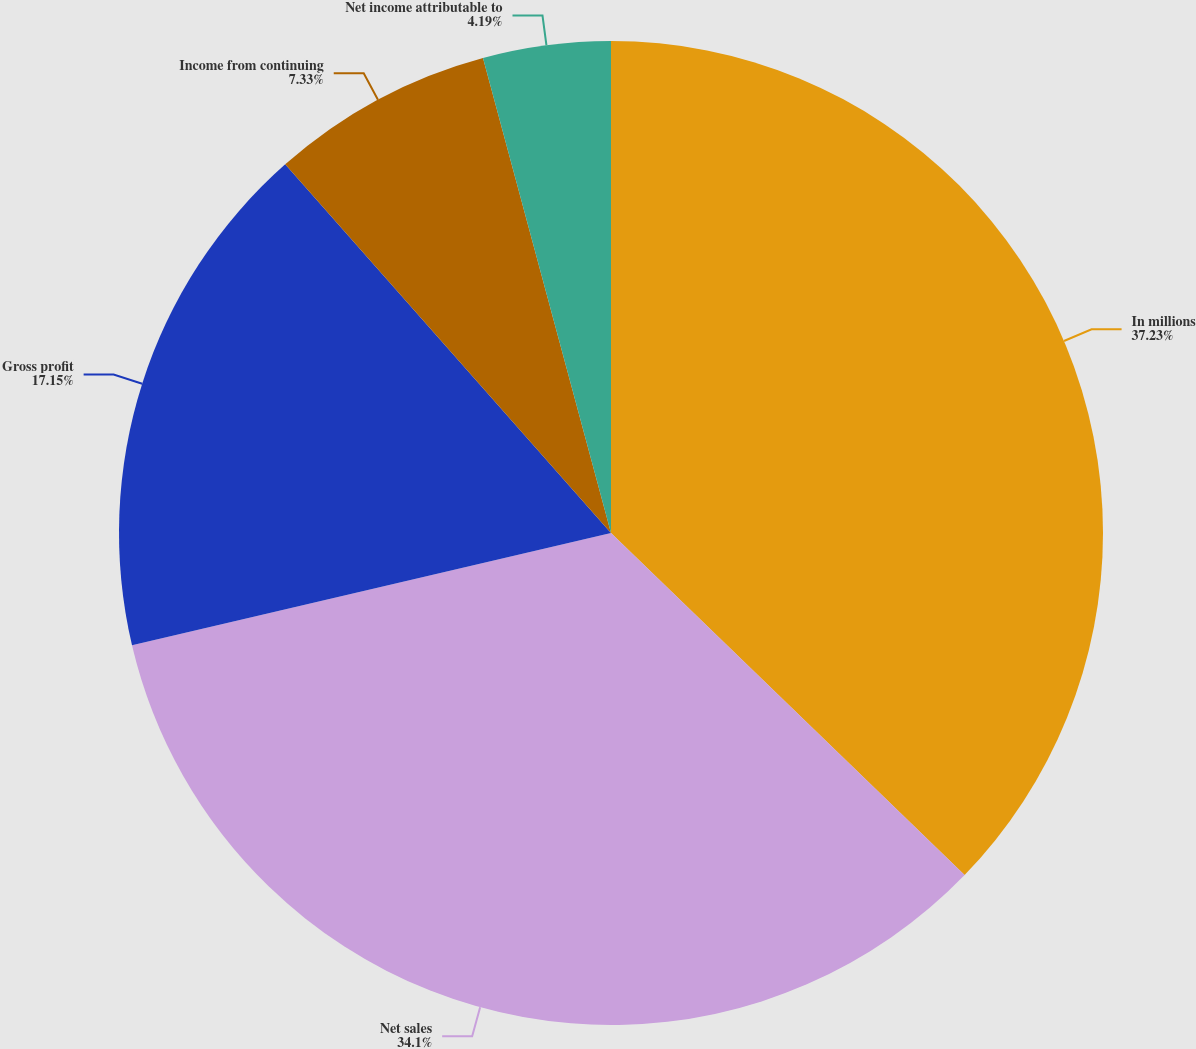Convert chart to OTSL. <chart><loc_0><loc_0><loc_500><loc_500><pie_chart><fcel>In millions<fcel>Net sales<fcel>Gross profit<fcel>Income from continuing<fcel>Net income attributable to<nl><fcel>37.24%<fcel>34.1%<fcel>17.15%<fcel>7.33%<fcel>4.19%<nl></chart> 